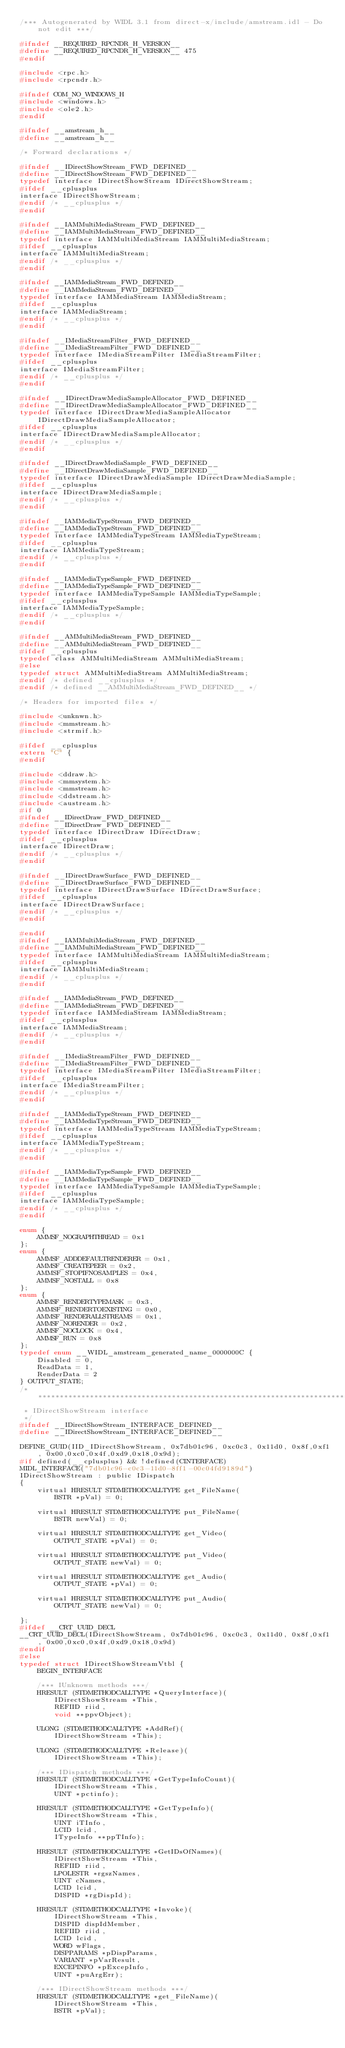<code> <loc_0><loc_0><loc_500><loc_500><_C_>/*** Autogenerated by WIDL 3.1 from direct-x/include/amstream.idl - Do not edit ***/

#ifndef __REQUIRED_RPCNDR_H_VERSION__
#define __REQUIRED_RPCNDR_H_VERSION__ 475
#endif

#include <rpc.h>
#include <rpcndr.h>

#ifndef COM_NO_WINDOWS_H
#include <windows.h>
#include <ole2.h>
#endif

#ifndef __amstream_h__
#define __amstream_h__

/* Forward declarations */

#ifndef __IDirectShowStream_FWD_DEFINED__
#define __IDirectShowStream_FWD_DEFINED__
typedef interface IDirectShowStream IDirectShowStream;
#ifdef __cplusplus
interface IDirectShowStream;
#endif /* __cplusplus */
#endif

#ifndef __IAMMultiMediaStream_FWD_DEFINED__
#define __IAMMultiMediaStream_FWD_DEFINED__
typedef interface IAMMultiMediaStream IAMMultiMediaStream;
#ifdef __cplusplus
interface IAMMultiMediaStream;
#endif /* __cplusplus */
#endif

#ifndef __IAMMediaStream_FWD_DEFINED__
#define __IAMMediaStream_FWD_DEFINED__
typedef interface IAMMediaStream IAMMediaStream;
#ifdef __cplusplus
interface IAMMediaStream;
#endif /* __cplusplus */
#endif

#ifndef __IMediaStreamFilter_FWD_DEFINED__
#define __IMediaStreamFilter_FWD_DEFINED__
typedef interface IMediaStreamFilter IMediaStreamFilter;
#ifdef __cplusplus
interface IMediaStreamFilter;
#endif /* __cplusplus */
#endif

#ifndef __IDirectDrawMediaSampleAllocator_FWD_DEFINED__
#define __IDirectDrawMediaSampleAllocator_FWD_DEFINED__
typedef interface IDirectDrawMediaSampleAllocator IDirectDrawMediaSampleAllocator;
#ifdef __cplusplus
interface IDirectDrawMediaSampleAllocator;
#endif /* __cplusplus */
#endif

#ifndef __IDirectDrawMediaSample_FWD_DEFINED__
#define __IDirectDrawMediaSample_FWD_DEFINED__
typedef interface IDirectDrawMediaSample IDirectDrawMediaSample;
#ifdef __cplusplus
interface IDirectDrawMediaSample;
#endif /* __cplusplus */
#endif

#ifndef __IAMMediaTypeStream_FWD_DEFINED__
#define __IAMMediaTypeStream_FWD_DEFINED__
typedef interface IAMMediaTypeStream IAMMediaTypeStream;
#ifdef __cplusplus
interface IAMMediaTypeStream;
#endif /* __cplusplus */
#endif

#ifndef __IAMMediaTypeSample_FWD_DEFINED__
#define __IAMMediaTypeSample_FWD_DEFINED__
typedef interface IAMMediaTypeSample IAMMediaTypeSample;
#ifdef __cplusplus
interface IAMMediaTypeSample;
#endif /* __cplusplus */
#endif

#ifndef __AMMultiMediaStream_FWD_DEFINED__
#define __AMMultiMediaStream_FWD_DEFINED__
#ifdef __cplusplus
typedef class AMMultiMediaStream AMMultiMediaStream;
#else
typedef struct AMMultiMediaStream AMMultiMediaStream;
#endif /* defined __cplusplus */
#endif /* defined __AMMultiMediaStream_FWD_DEFINED__ */

/* Headers for imported files */

#include <unknwn.h>
#include <mmstream.h>
#include <strmif.h>

#ifdef __cplusplus
extern "C" {
#endif

#include <ddraw.h>
#include <mmsystem.h>
#include <mmstream.h>
#include <ddstream.h>
#include <austream.h>
#if 0
#ifndef __IDirectDraw_FWD_DEFINED__
#define __IDirectDraw_FWD_DEFINED__
typedef interface IDirectDraw IDirectDraw;
#ifdef __cplusplus
interface IDirectDraw;
#endif /* __cplusplus */
#endif

#ifndef __IDirectDrawSurface_FWD_DEFINED__
#define __IDirectDrawSurface_FWD_DEFINED__
typedef interface IDirectDrawSurface IDirectDrawSurface;
#ifdef __cplusplus
interface IDirectDrawSurface;
#endif /* __cplusplus */
#endif

#endif
#ifndef __IAMMultiMediaStream_FWD_DEFINED__
#define __IAMMultiMediaStream_FWD_DEFINED__
typedef interface IAMMultiMediaStream IAMMultiMediaStream;
#ifdef __cplusplus
interface IAMMultiMediaStream;
#endif /* __cplusplus */
#endif

#ifndef __IAMMediaStream_FWD_DEFINED__
#define __IAMMediaStream_FWD_DEFINED__
typedef interface IAMMediaStream IAMMediaStream;
#ifdef __cplusplus
interface IAMMediaStream;
#endif /* __cplusplus */
#endif

#ifndef __IMediaStreamFilter_FWD_DEFINED__
#define __IMediaStreamFilter_FWD_DEFINED__
typedef interface IMediaStreamFilter IMediaStreamFilter;
#ifdef __cplusplus
interface IMediaStreamFilter;
#endif /* __cplusplus */
#endif

#ifndef __IAMMediaTypeStream_FWD_DEFINED__
#define __IAMMediaTypeStream_FWD_DEFINED__
typedef interface IAMMediaTypeStream IAMMediaTypeStream;
#ifdef __cplusplus
interface IAMMediaTypeStream;
#endif /* __cplusplus */
#endif

#ifndef __IAMMediaTypeSample_FWD_DEFINED__
#define __IAMMediaTypeSample_FWD_DEFINED__
typedef interface IAMMediaTypeSample IAMMediaTypeSample;
#ifdef __cplusplus
interface IAMMediaTypeSample;
#endif /* __cplusplus */
#endif

enum {
    AMMSF_NOGRAPHTHREAD = 0x1
};
enum {
    AMMSF_ADDDEFAULTRENDERER = 0x1,
    AMMSF_CREATEPEER = 0x2,
    AMMSF_STOPIFNOSAMPLES = 0x4,
    AMMSF_NOSTALL = 0x8
};
enum {
    AMMSF_RENDERTYPEMASK = 0x3,
    AMMSF_RENDERTOEXISTING = 0x0,
    AMMSF_RENDERALLSTREAMS = 0x1,
    AMMSF_NORENDER = 0x2,
    AMMSF_NOCLOCK = 0x4,
    AMMSF_RUN = 0x8
};
typedef enum __WIDL_amstream_generated_name_0000000C {
    Disabled = 0,
    ReadData = 1,
    RenderData = 2
} OUTPUT_STATE;
/*****************************************************************************
 * IDirectShowStream interface
 */
#ifndef __IDirectShowStream_INTERFACE_DEFINED__
#define __IDirectShowStream_INTERFACE_DEFINED__

DEFINE_GUID(IID_IDirectShowStream, 0x7db01c96, 0xc0c3, 0x11d0, 0x8f,0xf1, 0x00,0xc0,0x4f,0xd9,0x18,0x9d);
#if defined(__cplusplus) && !defined(CINTERFACE)
MIDL_INTERFACE("7db01c96-c0c3-11d0-8ff1-00c04fd9189d")
IDirectShowStream : public IDispatch
{
    virtual HRESULT STDMETHODCALLTYPE get_FileName(
        BSTR *pVal) = 0;

    virtual HRESULT STDMETHODCALLTYPE put_FileName(
        BSTR newVal) = 0;

    virtual HRESULT STDMETHODCALLTYPE get_Video(
        OUTPUT_STATE *pVal) = 0;

    virtual HRESULT STDMETHODCALLTYPE put_Video(
        OUTPUT_STATE newVal) = 0;

    virtual HRESULT STDMETHODCALLTYPE get_Audio(
        OUTPUT_STATE *pVal) = 0;

    virtual HRESULT STDMETHODCALLTYPE put_Audio(
        OUTPUT_STATE newVal) = 0;

};
#ifdef __CRT_UUID_DECL
__CRT_UUID_DECL(IDirectShowStream, 0x7db01c96, 0xc0c3, 0x11d0, 0x8f,0xf1, 0x00,0xc0,0x4f,0xd9,0x18,0x9d)
#endif
#else
typedef struct IDirectShowStreamVtbl {
    BEGIN_INTERFACE

    /*** IUnknown methods ***/
    HRESULT (STDMETHODCALLTYPE *QueryInterface)(
        IDirectShowStream *This,
        REFIID riid,
        void **ppvObject);

    ULONG (STDMETHODCALLTYPE *AddRef)(
        IDirectShowStream *This);

    ULONG (STDMETHODCALLTYPE *Release)(
        IDirectShowStream *This);

    /*** IDispatch methods ***/
    HRESULT (STDMETHODCALLTYPE *GetTypeInfoCount)(
        IDirectShowStream *This,
        UINT *pctinfo);

    HRESULT (STDMETHODCALLTYPE *GetTypeInfo)(
        IDirectShowStream *This,
        UINT iTInfo,
        LCID lcid,
        ITypeInfo **ppTInfo);

    HRESULT (STDMETHODCALLTYPE *GetIDsOfNames)(
        IDirectShowStream *This,
        REFIID riid,
        LPOLESTR *rgszNames,
        UINT cNames,
        LCID lcid,
        DISPID *rgDispId);

    HRESULT (STDMETHODCALLTYPE *Invoke)(
        IDirectShowStream *This,
        DISPID dispIdMember,
        REFIID riid,
        LCID lcid,
        WORD wFlags,
        DISPPARAMS *pDispParams,
        VARIANT *pVarResult,
        EXCEPINFO *pExcepInfo,
        UINT *puArgErr);

    /*** IDirectShowStream methods ***/
    HRESULT (STDMETHODCALLTYPE *get_FileName)(
        IDirectShowStream *This,
        BSTR *pVal);
</code> 